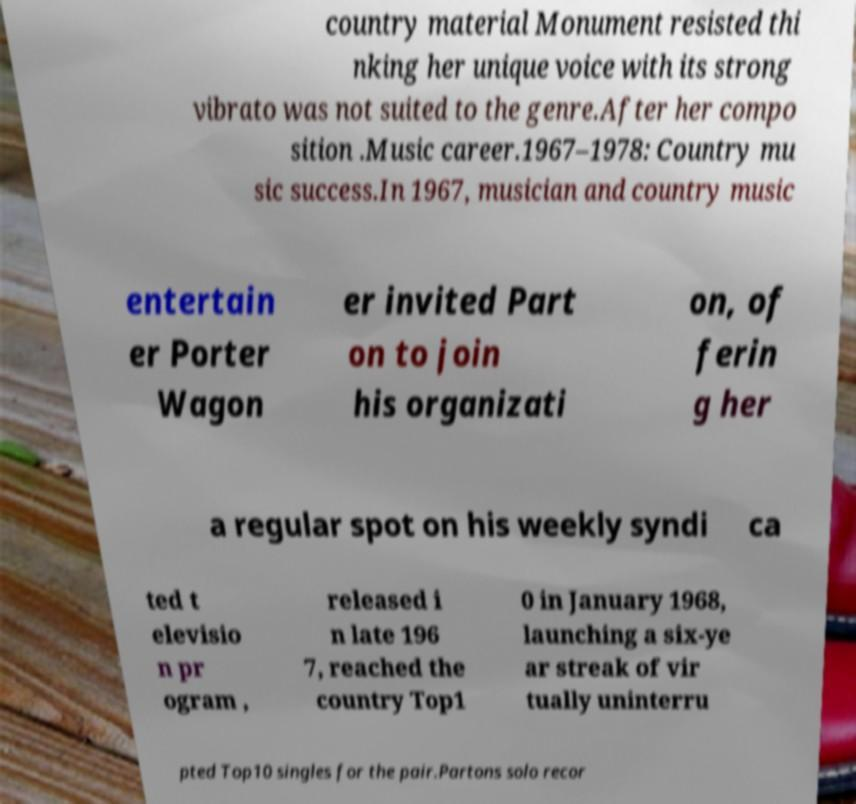Can you accurately transcribe the text from the provided image for me? country material Monument resisted thi nking her unique voice with its strong vibrato was not suited to the genre.After her compo sition .Music career.1967–1978: Country mu sic success.In 1967, musician and country music entertain er Porter Wagon er invited Part on to join his organizati on, of ferin g her a regular spot on his weekly syndi ca ted t elevisio n pr ogram , released i n late 196 7, reached the country Top1 0 in January 1968, launching a six-ye ar streak of vir tually uninterru pted Top10 singles for the pair.Partons solo recor 